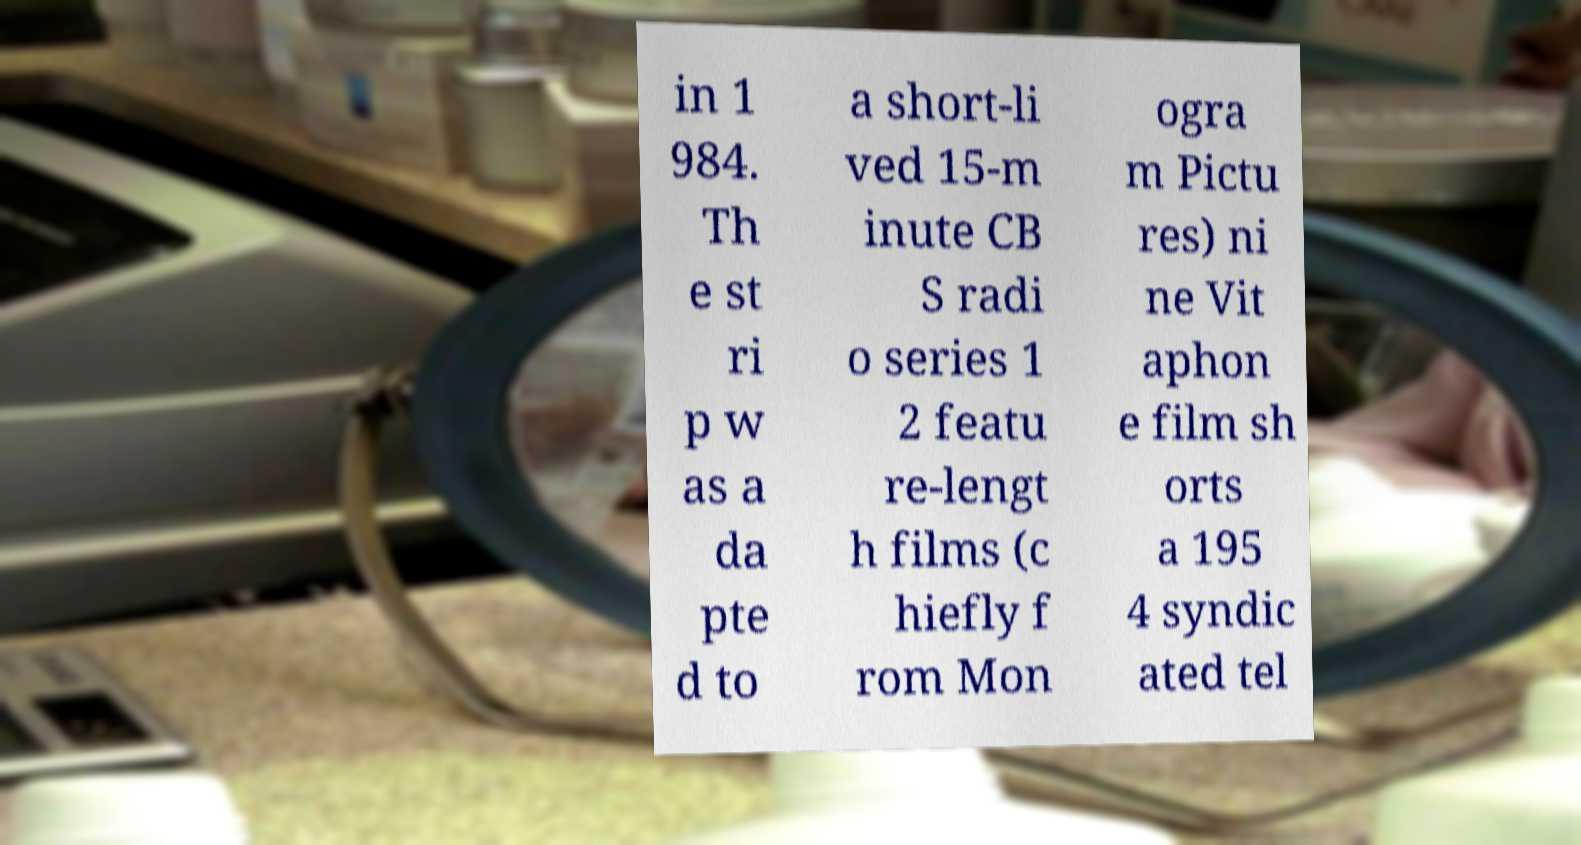For documentation purposes, I need the text within this image transcribed. Could you provide that? in 1 984. Th e st ri p w as a da pte d to a short-li ved 15-m inute CB S radi o series 1 2 featu re-lengt h films (c hiefly f rom Mon ogra m Pictu res) ni ne Vit aphon e film sh orts a 195 4 syndic ated tel 